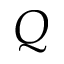<formula> <loc_0><loc_0><loc_500><loc_500>Q</formula> 